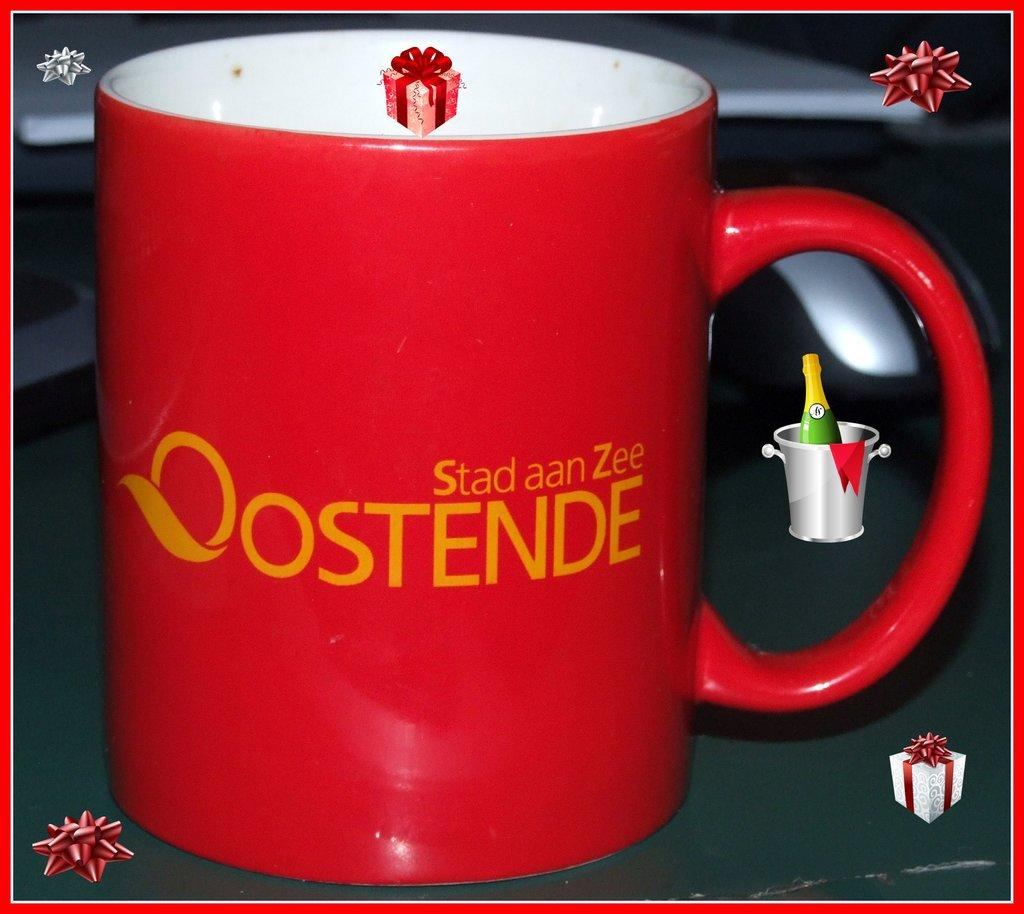Provide a one-sentence caption for the provided image. A red coffee mug with the words "Stad aan Zee Oostende" on it. 